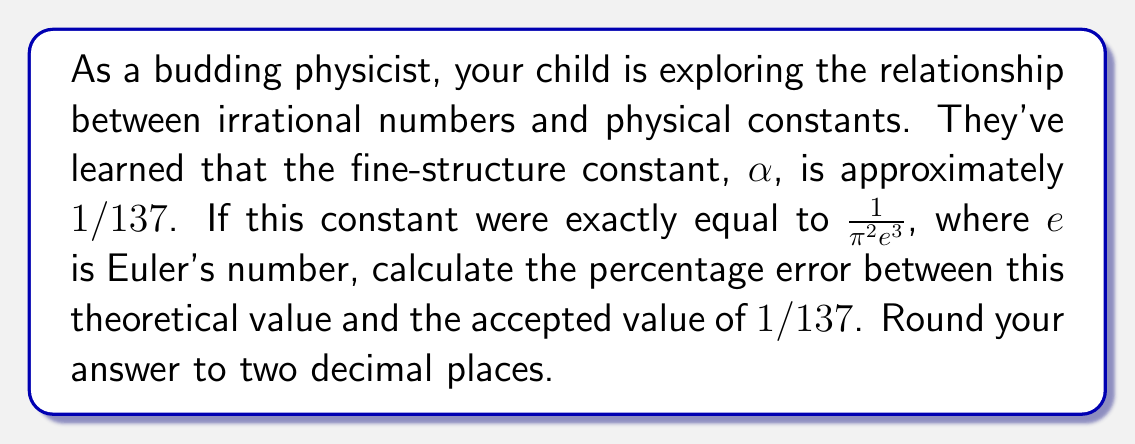Help me with this question. Let's approach this step-by-step:

1) First, we need to calculate the theoretical value of α based on the given formula:

   $\alpha_{theoretical} = \frac{1}{\pi^2 e^3}$

2) We know the values of π and e:
   π ≈ 3.14159
   e ≈ 2.71828

3) Let's substitute these values:

   $\alpha_{theoretical} = \frac{1}{(3.14159)^2 (2.71828)^3}$

4) Calculating this:

   $\alpha_{theoretical} \approx 0.007297352$

5) Now, let's calculate the accepted value:

   $\alpha_{accepted} = \frac{1}{137} \approx 0.007299270$

6) To calculate the percentage error, we use the formula:

   $\text{Percentage Error} = \left|\frac{\text{Accepted Value} - \text{Theoretical Value}}{\text{Accepted Value}}\right| \times 100\%$

7) Substituting our values:

   $\text{Percentage Error} = \left|\frac{0.007299270 - 0.007297352}{0.007299270}\right| \times 100\%$

8) Calculating this:

   $\text{Percentage Error} \approx 0.02629\%$

9) Rounding to two decimal places:

   $\text{Percentage Error} \approx 0.03\%$
Answer: 0.03% 